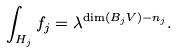Convert formula to latex. <formula><loc_0><loc_0><loc_500><loc_500>\int _ { H _ { j } } f _ { j } = \lambda ^ { \dim ( B _ { j } V ) - n _ { j } } .</formula> 